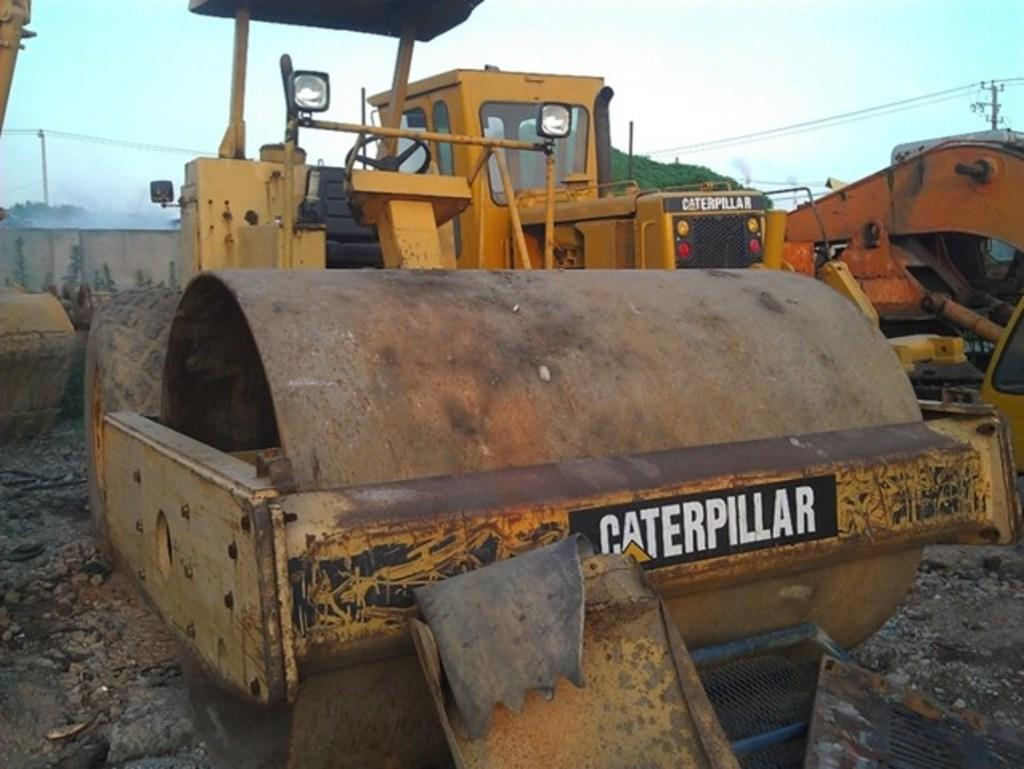What types of objects can be seen in the image? There are vehicles in the image. What else can be seen in the image besides vehicles? There are trees in the image. What part of the natural environment is visible in the image? The sky is visible in the image. What type of fear does the uncle have in the image? There is no uncle present in the image, so it is not possible to determine any fears they might have. 